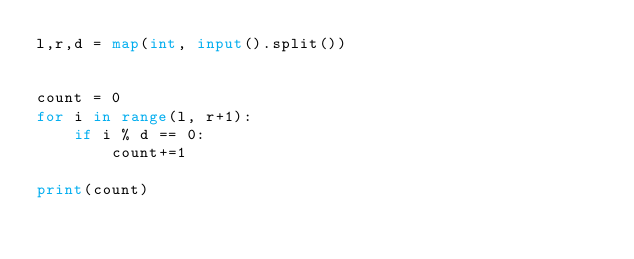Convert code to text. <code><loc_0><loc_0><loc_500><loc_500><_Python_>l,r,d = map(int, input().split())


count = 0
for i in range(l, r+1):
    if i % d == 0:
        count+=1

print(count)</code> 